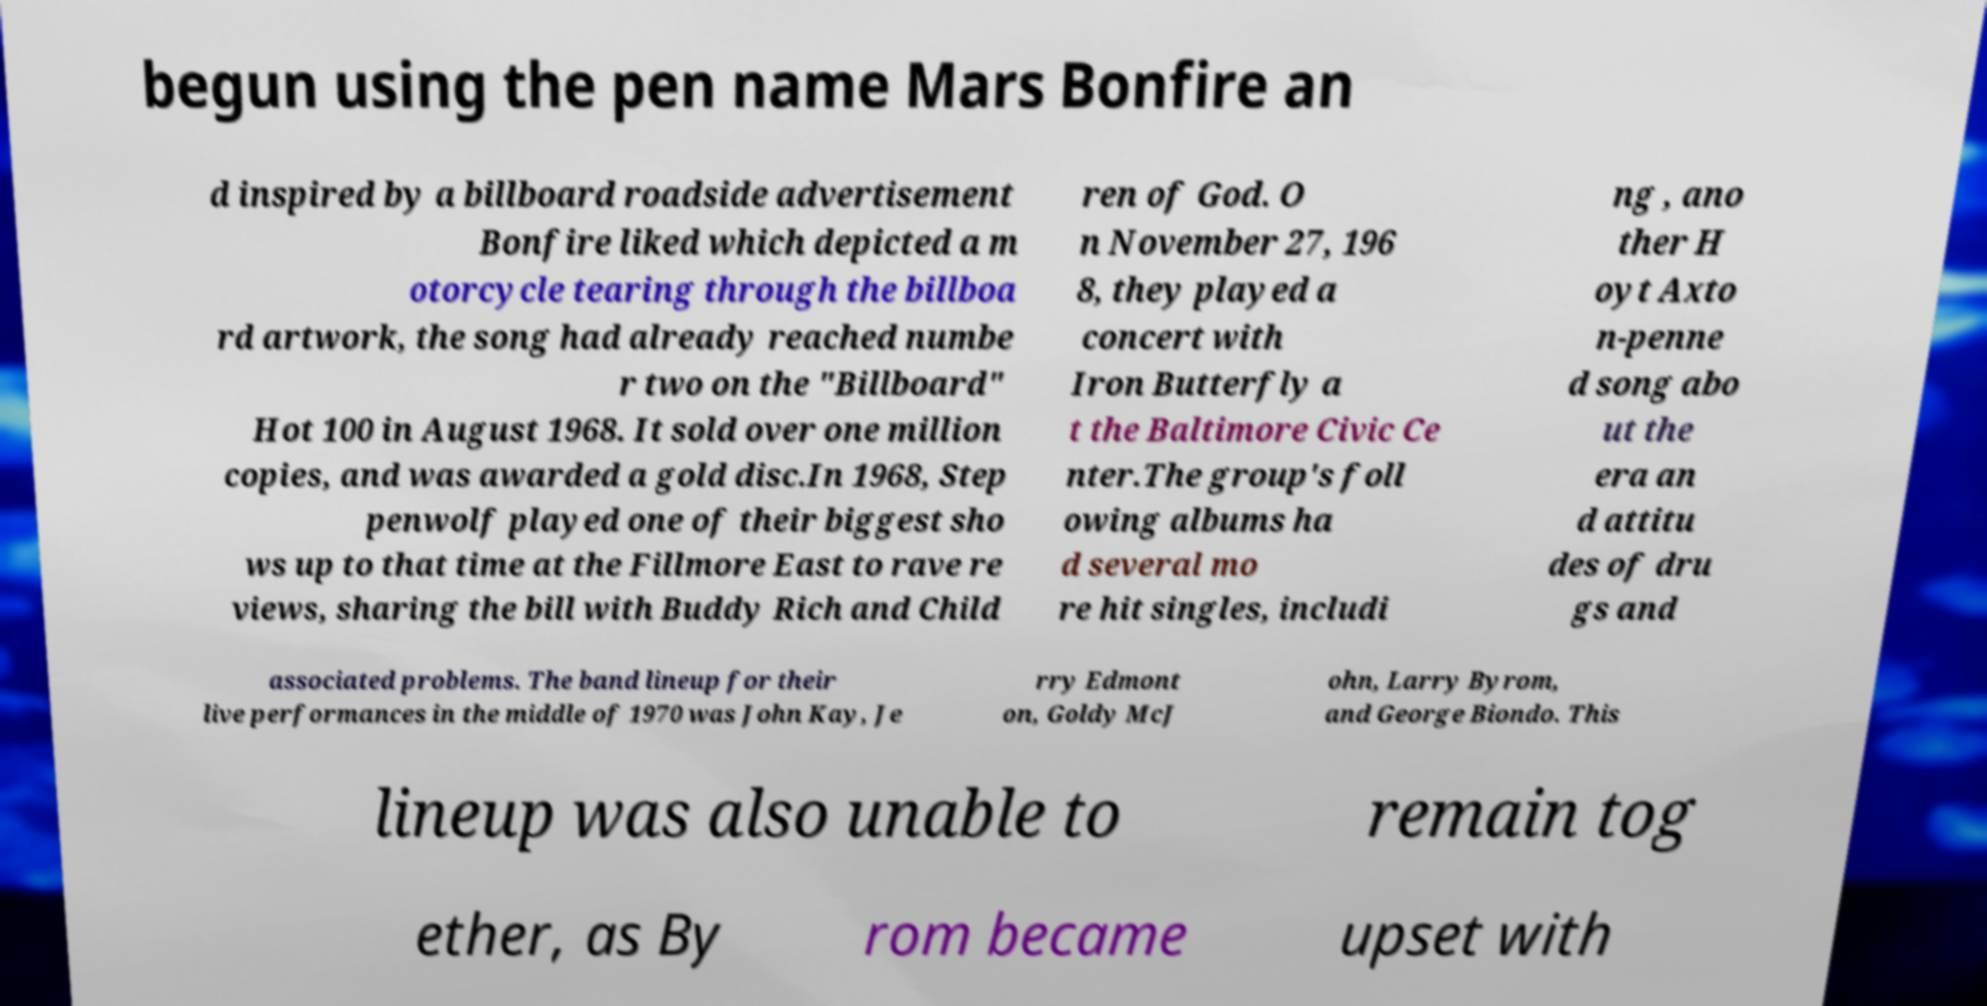Can you accurately transcribe the text from the provided image for me? begun using the pen name Mars Bonfire an d inspired by a billboard roadside advertisement Bonfire liked which depicted a m otorcycle tearing through the billboa rd artwork, the song had already reached numbe r two on the "Billboard" Hot 100 in August 1968. It sold over one million copies, and was awarded a gold disc.In 1968, Step penwolf played one of their biggest sho ws up to that time at the Fillmore East to rave re views, sharing the bill with Buddy Rich and Child ren of God. O n November 27, 196 8, they played a concert with Iron Butterfly a t the Baltimore Civic Ce nter.The group's foll owing albums ha d several mo re hit singles, includi ng , ano ther H oyt Axto n-penne d song abo ut the era an d attitu des of dru gs and associated problems. The band lineup for their live performances in the middle of 1970 was John Kay, Je rry Edmont on, Goldy McJ ohn, Larry Byrom, and George Biondo. This lineup was also unable to remain tog ether, as By rom became upset with 